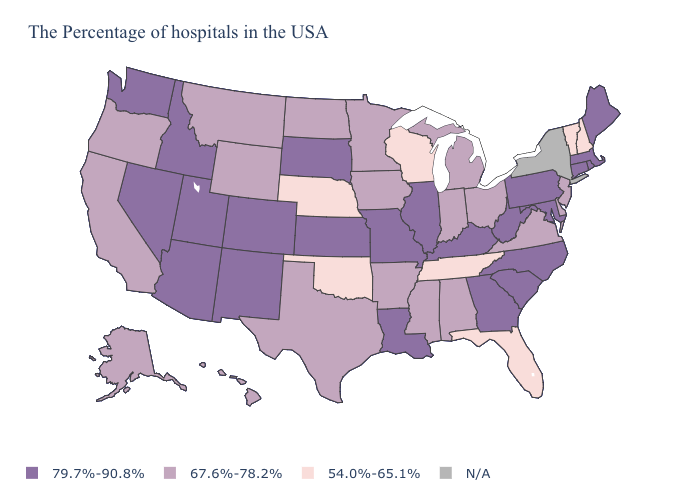Among the states that border Indiana , which have the highest value?
Keep it brief. Kentucky, Illinois. Name the states that have a value in the range 67.6%-78.2%?
Give a very brief answer. New Jersey, Delaware, Virginia, Ohio, Michigan, Indiana, Alabama, Mississippi, Arkansas, Minnesota, Iowa, Texas, North Dakota, Wyoming, Montana, California, Oregon, Alaska, Hawaii. How many symbols are there in the legend?
Concise answer only. 4. Name the states that have a value in the range 79.7%-90.8%?
Give a very brief answer. Maine, Massachusetts, Rhode Island, Connecticut, Maryland, Pennsylvania, North Carolina, South Carolina, West Virginia, Georgia, Kentucky, Illinois, Louisiana, Missouri, Kansas, South Dakota, Colorado, New Mexico, Utah, Arizona, Idaho, Nevada, Washington. Does the map have missing data?
Give a very brief answer. Yes. What is the lowest value in states that border North Dakota?
Answer briefly. 67.6%-78.2%. Name the states that have a value in the range 67.6%-78.2%?
Write a very short answer. New Jersey, Delaware, Virginia, Ohio, Michigan, Indiana, Alabama, Mississippi, Arkansas, Minnesota, Iowa, Texas, North Dakota, Wyoming, Montana, California, Oregon, Alaska, Hawaii. What is the value of Wyoming?
Short answer required. 67.6%-78.2%. Which states have the highest value in the USA?
Answer briefly. Maine, Massachusetts, Rhode Island, Connecticut, Maryland, Pennsylvania, North Carolina, South Carolina, West Virginia, Georgia, Kentucky, Illinois, Louisiana, Missouri, Kansas, South Dakota, Colorado, New Mexico, Utah, Arizona, Idaho, Nevada, Washington. Which states hav the highest value in the Northeast?
Answer briefly. Maine, Massachusetts, Rhode Island, Connecticut, Pennsylvania. Does Nevada have the lowest value in the West?
Give a very brief answer. No. Which states have the highest value in the USA?
Write a very short answer. Maine, Massachusetts, Rhode Island, Connecticut, Maryland, Pennsylvania, North Carolina, South Carolina, West Virginia, Georgia, Kentucky, Illinois, Louisiana, Missouri, Kansas, South Dakota, Colorado, New Mexico, Utah, Arizona, Idaho, Nevada, Washington. Name the states that have a value in the range 67.6%-78.2%?
Short answer required. New Jersey, Delaware, Virginia, Ohio, Michigan, Indiana, Alabama, Mississippi, Arkansas, Minnesota, Iowa, Texas, North Dakota, Wyoming, Montana, California, Oregon, Alaska, Hawaii. 